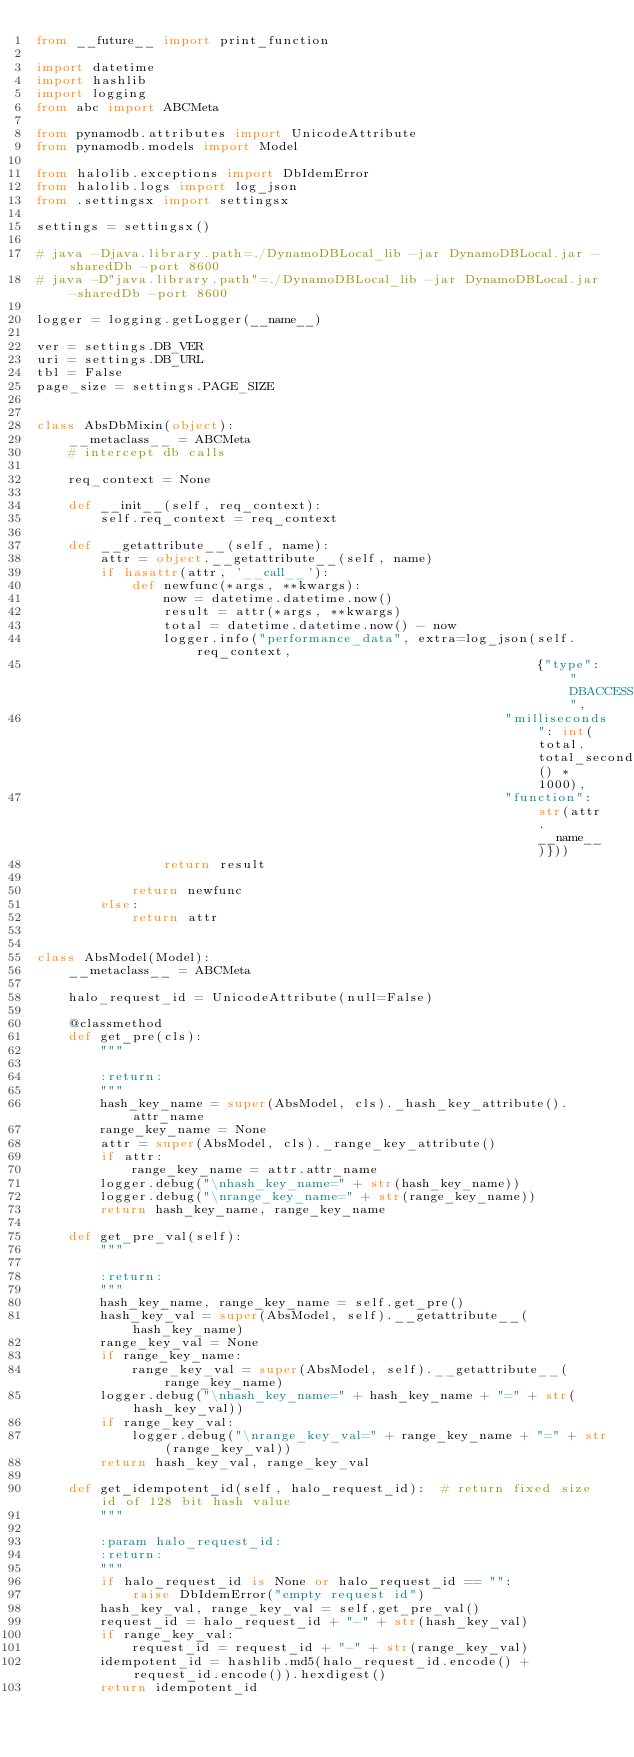Convert code to text. <code><loc_0><loc_0><loc_500><loc_500><_Python_>from __future__ import print_function

import datetime
import hashlib
import logging
from abc import ABCMeta

from pynamodb.attributes import UnicodeAttribute
from pynamodb.models import Model

from halolib.exceptions import DbIdemError
from halolib.logs import log_json
from .settingsx import settingsx

settings = settingsx()

# java -Djava.library.path=./DynamoDBLocal_lib -jar DynamoDBLocal.jar -sharedDb -port 8600
# java -D"java.library.path"=./DynamoDBLocal_lib -jar DynamoDBLocal.jar -sharedDb -port 8600

logger = logging.getLogger(__name__)

ver = settings.DB_VER
uri = settings.DB_URL
tbl = False
page_size = settings.PAGE_SIZE


class AbsDbMixin(object):
    __metaclass__ = ABCMeta
    # intercept db calls

    req_context = None

    def __init__(self, req_context):
        self.req_context = req_context

    def __getattribute__(self, name):
        attr = object.__getattribute__(self, name)
        if hasattr(attr, '__call__'):
            def newfunc(*args, **kwargs):
                now = datetime.datetime.now()
                result = attr(*args, **kwargs)
                total = datetime.datetime.now() - now
                logger.info("performance_data", extra=log_json(self.req_context,
                                                               {"type": "DBACCESS",
                                                           "milliseconds": int(total.total_seconds() * 1000),
                                                           "function": str(attr.__name__)}))
                return result

            return newfunc
        else:
            return attr


class AbsModel(Model):
    __metaclass__ = ABCMeta

    halo_request_id = UnicodeAttribute(null=False)

    @classmethod
    def get_pre(cls):
        """

        :return:
        """
        hash_key_name = super(AbsModel, cls)._hash_key_attribute().attr_name
        range_key_name = None
        attr = super(AbsModel, cls)._range_key_attribute()
        if attr:
            range_key_name = attr.attr_name
        logger.debug("\nhash_key_name=" + str(hash_key_name))
        logger.debug("\nrange_key_name=" + str(range_key_name))
        return hash_key_name, range_key_name

    def get_pre_val(self):
        """

        :return:
        """
        hash_key_name, range_key_name = self.get_pre()
        hash_key_val = super(AbsModel, self).__getattribute__(hash_key_name)
        range_key_val = None
        if range_key_name:
            range_key_val = super(AbsModel, self).__getattribute__(range_key_name)
        logger.debug("\nhash_key_name=" + hash_key_name + "=" + str(hash_key_val))
        if range_key_val:
            logger.debug("\nrange_key_val=" + range_key_name + "=" + str(range_key_val))
        return hash_key_val, range_key_val

    def get_idempotent_id(self, halo_request_id):  # return fixed size id of 128 bit hash value
        """

        :param halo_request_id:
        :return:
        """
        if halo_request_id is None or halo_request_id == "":
            raise DbIdemError("empty request id")
        hash_key_val, range_key_val = self.get_pre_val()
        request_id = halo_request_id + "-" + str(hash_key_val)
        if range_key_val:
            request_id = request_id + "-" + str(range_key_val)
        idempotent_id = hashlib.md5(halo_request_id.encode() + request_id.encode()).hexdigest()
        return idempotent_id

</code> 